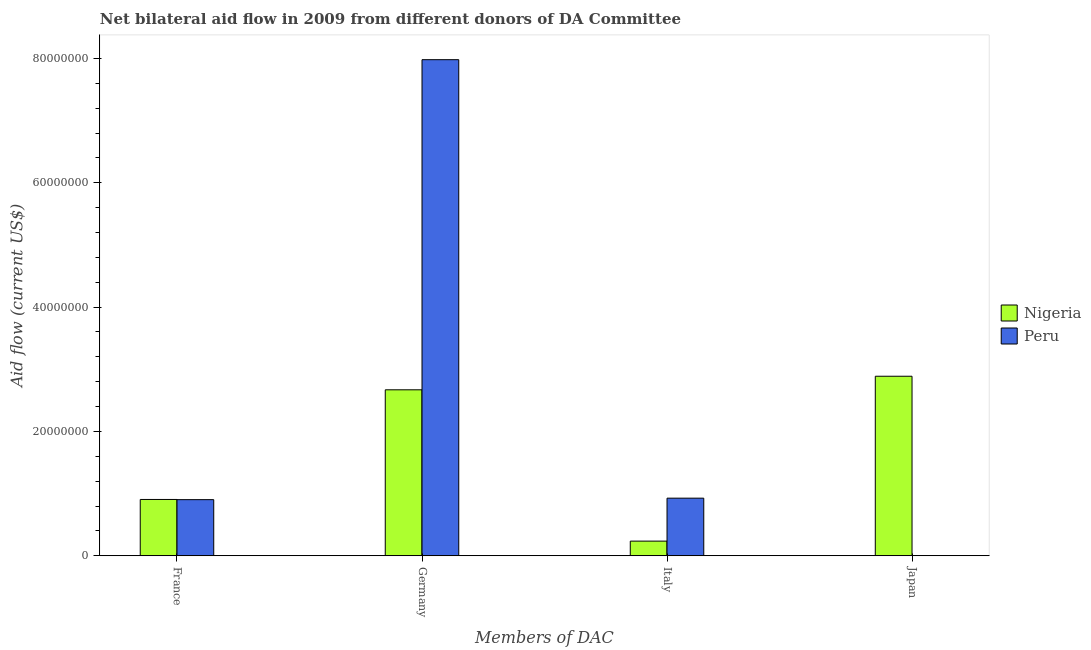Are the number of bars per tick equal to the number of legend labels?
Give a very brief answer. No. Are the number of bars on each tick of the X-axis equal?
Your response must be concise. No. How many bars are there on the 4th tick from the right?
Give a very brief answer. 2. What is the label of the 2nd group of bars from the left?
Your answer should be very brief. Germany. What is the amount of aid given by germany in Peru?
Offer a terse response. 7.98e+07. Across all countries, what is the maximum amount of aid given by japan?
Your answer should be very brief. 2.89e+07. In which country was the amount of aid given by japan maximum?
Your answer should be compact. Nigeria. What is the total amount of aid given by italy in the graph?
Offer a very short reply. 1.16e+07. What is the difference between the amount of aid given by germany in Nigeria and that in Peru?
Offer a terse response. -5.31e+07. What is the difference between the amount of aid given by italy in Peru and the amount of aid given by germany in Nigeria?
Your answer should be very brief. -1.74e+07. What is the average amount of aid given by france per country?
Provide a short and direct response. 9.04e+06. What is the difference between the amount of aid given by italy and amount of aid given by france in Nigeria?
Offer a very short reply. -6.70e+06. What is the ratio of the amount of aid given by france in Nigeria to that in Peru?
Your answer should be very brief. 1. Is the amount of aid given by italy in Nigeria less than that in Peru?
Provide a short and direct response. Yes. Is the difference between the amount of aid given by france in Peru and Nigeria greater than the difference between the amount of aid given by germany in Peru and Nigeria?
Your answer should be very brief. No. What is the difference between the highest and the lowest amount of aid given by france?
Provide a short and direct response. 3.00e+04. In how many countries, is the amount of aid given by france greater than the average amount of aid given by france taken over all countries?
Make the answer very short. 1. Is it the case that in every country, the sum of the amount of aid given by france and amount of aid given by germany is greater than the amount of aid given by italy?
Your answer should be compact. Yes. How many bars are there?
Give a very brief answer. 7. Are all the bars in the graph horizontal?
Offer a terse response. No. Are the values on the major ticks of Y-axis written in scientific E-notation?
Your answer should be very brief. No. Does the graph contain grids?
Your answer should be very brief. No. What is the title of the graph?
Give a very brief answer. Net bilateral aid flow in 2009 from different donors of DA Committee. Does "Mali" appear as one of the legend labels in the graph?
Make the answer very short. No. What is the label or title of the X-axis?
Ensure brevity in your answer.  Members of DAC. What is the label or title of the Y-axis?
Offer a very short reply. Aid flow (current US$). What is the Aid flow (current US$) in Nigeria in France?
Provide a succinct answer. 9.06e+06. What is the Aid flow (current US$) of Peru in France?
Give a very brief answer. 9.03e+06. What is the Aid flow (current US$) in Nigeria in Germany?
Keep it short and to the point. 2.67e+07. What is the Aid flow (current US$) in Peru in Germany?
Provide a succinct answer. 7.98e+07. What is the Aid flow (current US$) in Nigeria in Italy?
Provide a short and direct response. 2.36e+06. What is the Aid flow (current US$) of Peru in Italy?
Your response must be concise. 9.27e+06. What is the Aid flow (current US$) in Nigeria in Japan?
Provide a succinct answer. 2.89e+07. Across all Members of DAC, what is the maximum Aid flow (current US$) in Nigeria?
Your answer should be very brief. 2.89e+07. Across all Members of DAC, what is the maximum Aid flow (current US$) in Peru?
Offer a very short reply. 7.98e+07. Across all Members of DAC, what is the minimum Aid flow (current US$) of Nigeria?
Offer a very short reply. 2.36e+06. Across all Members of DAC, what is the minimum Aid flow (current US$) in Peru?
Offer a terse response. 0. What is the total Aid flow (current US$) in Nigeria in the graph?
Give a very brief answer. 6.70e+07. What is the total Aid flow (current US$) in Peru in the graph?
Keep it short and to the point. 9.81e+07. What is the difference between the Aid flow (current US$) in Nigeria in France and that in Germany?
Give a very brief answer. -1.76e+07. What is the difference between the Aid flow (current US$) of Peru in France and that in Germany?
Your answer should be very brief. -7.08e+07. What is the difference between the Aid flow (current US$) in Nigeria in France and that in Italy?
Make the answer very short. 6.70e+06. What is the difference between the Aid flow (current US$) of Peru in France and that in Italy?
Give a very brief answer. -2.40e+05. What is the difference between the Aid flow (current US$) in Nigeria in France and that in Japan?
Make the answer very short. -1.98e+07. What is the difference between the Aid flow (current US$) of Nigeria in Germany and that in Italy?
Provide a short and direct response. 2.43e+07. What is the difference between the Aid flow (current US$) in Peru in Germany and that in Italy?
Your answer should be very brief. 7.05e+07. What is the difference between the Aid flow (current US$) of Nigeria in Germany and that in Japan?
Your response must be concise. -2.18e+06. What is the difference between the Aid flow (current US$) of Nigeria in Italy and that in Japan?
Give a very brief answer. -2.65e+07. What is the difference between the Aid flow (current US$) of Nigeria in France and the Aid flow (current US$) of Peru in Germany?
Make the answer very short. -7.07e+07. What is the difference between the Aid flow (current US$) of Nigeria in France and the Aid flow (current US$) of Peru in Italy?
Your response must be concise. -2.10e+05. What is the difference between the Aid flow (current US$) of Nigeria in Germany and the Aid flow (current US$) of Peru in Italy?
Provide a succinct answer. 1.74e+07. What is the average Aid flow (current US$) of Nigeria per Members of DAC?
Provide a short and direct response. 1.68e+07. What is the average Aid flow (current US$) of Peru per Members of DAC?
Offer a very short reply. 2.45e+07. What is the difference between the Aid flow (current US$) in Nigeria and Aid flow (current US$) in Peru in Germany?
Your response must be concise. -5.31e+07. What is the difference between the Aid flow (current US$) of Nigeria and Aid flow (current US$) of Peru in Italy?
Provide a short and direct response. -6.91e+06. What is the ratio of the Aid flow (current US$) of Nigeria in France to that in Germany?
Your answer should be compact. 0.34. What is the ratio of the Aid flow (current US$) in Peru in France to that in Germany?
Your answer should be very brief. 0.11. What is the ratio of the Aid flow (current US$) in Nigeria in France to that in Italy?
Your response must be concise. 3.84. What is the ratio of the Aid flow (current US$) of Peru in France to that in Italy?
Offer a very short reply. 0.97. What is the ratio of the Aid flow (current US$) of Nigeria in France to that in Japan?
Offer a very short reply. 0.31. What is the ratio of the Aid flow (current US$) in Nigeria in Germany to that in Italy?
Offer a terse response. 11.31. What is the ratio of the Aid flow (current US$) in Peru in Germany to that in Italy?
Make the answer very short. 8.61. What is the ratio of the Aid flow (current US$) in Nigeria in Germany to that in Japan?
Give a very brief answer. 0.92. What is the ratio of the Aid flow (current US$) of Nigeria in Italy to that in Japan?
Offer a very short reply. 0.08. What is the difference between the highest and the second highest Aid flow (current US$) in Nigeria?
Your response must be concise. 2.18e+06. What is the difference between the highest and the second highest Aid flow (current US$) in Peru?
Your answer should be very brief. 7.05e+07. What is the difference between the highest and the lowest Aid flow (current US$) of Nigeria?
Make the answer very short. 2.65e+07. What is the difference between the highest and the lowest Aid flow (current US$) in Peru?
Your response must be concise. 7.98e+07. 